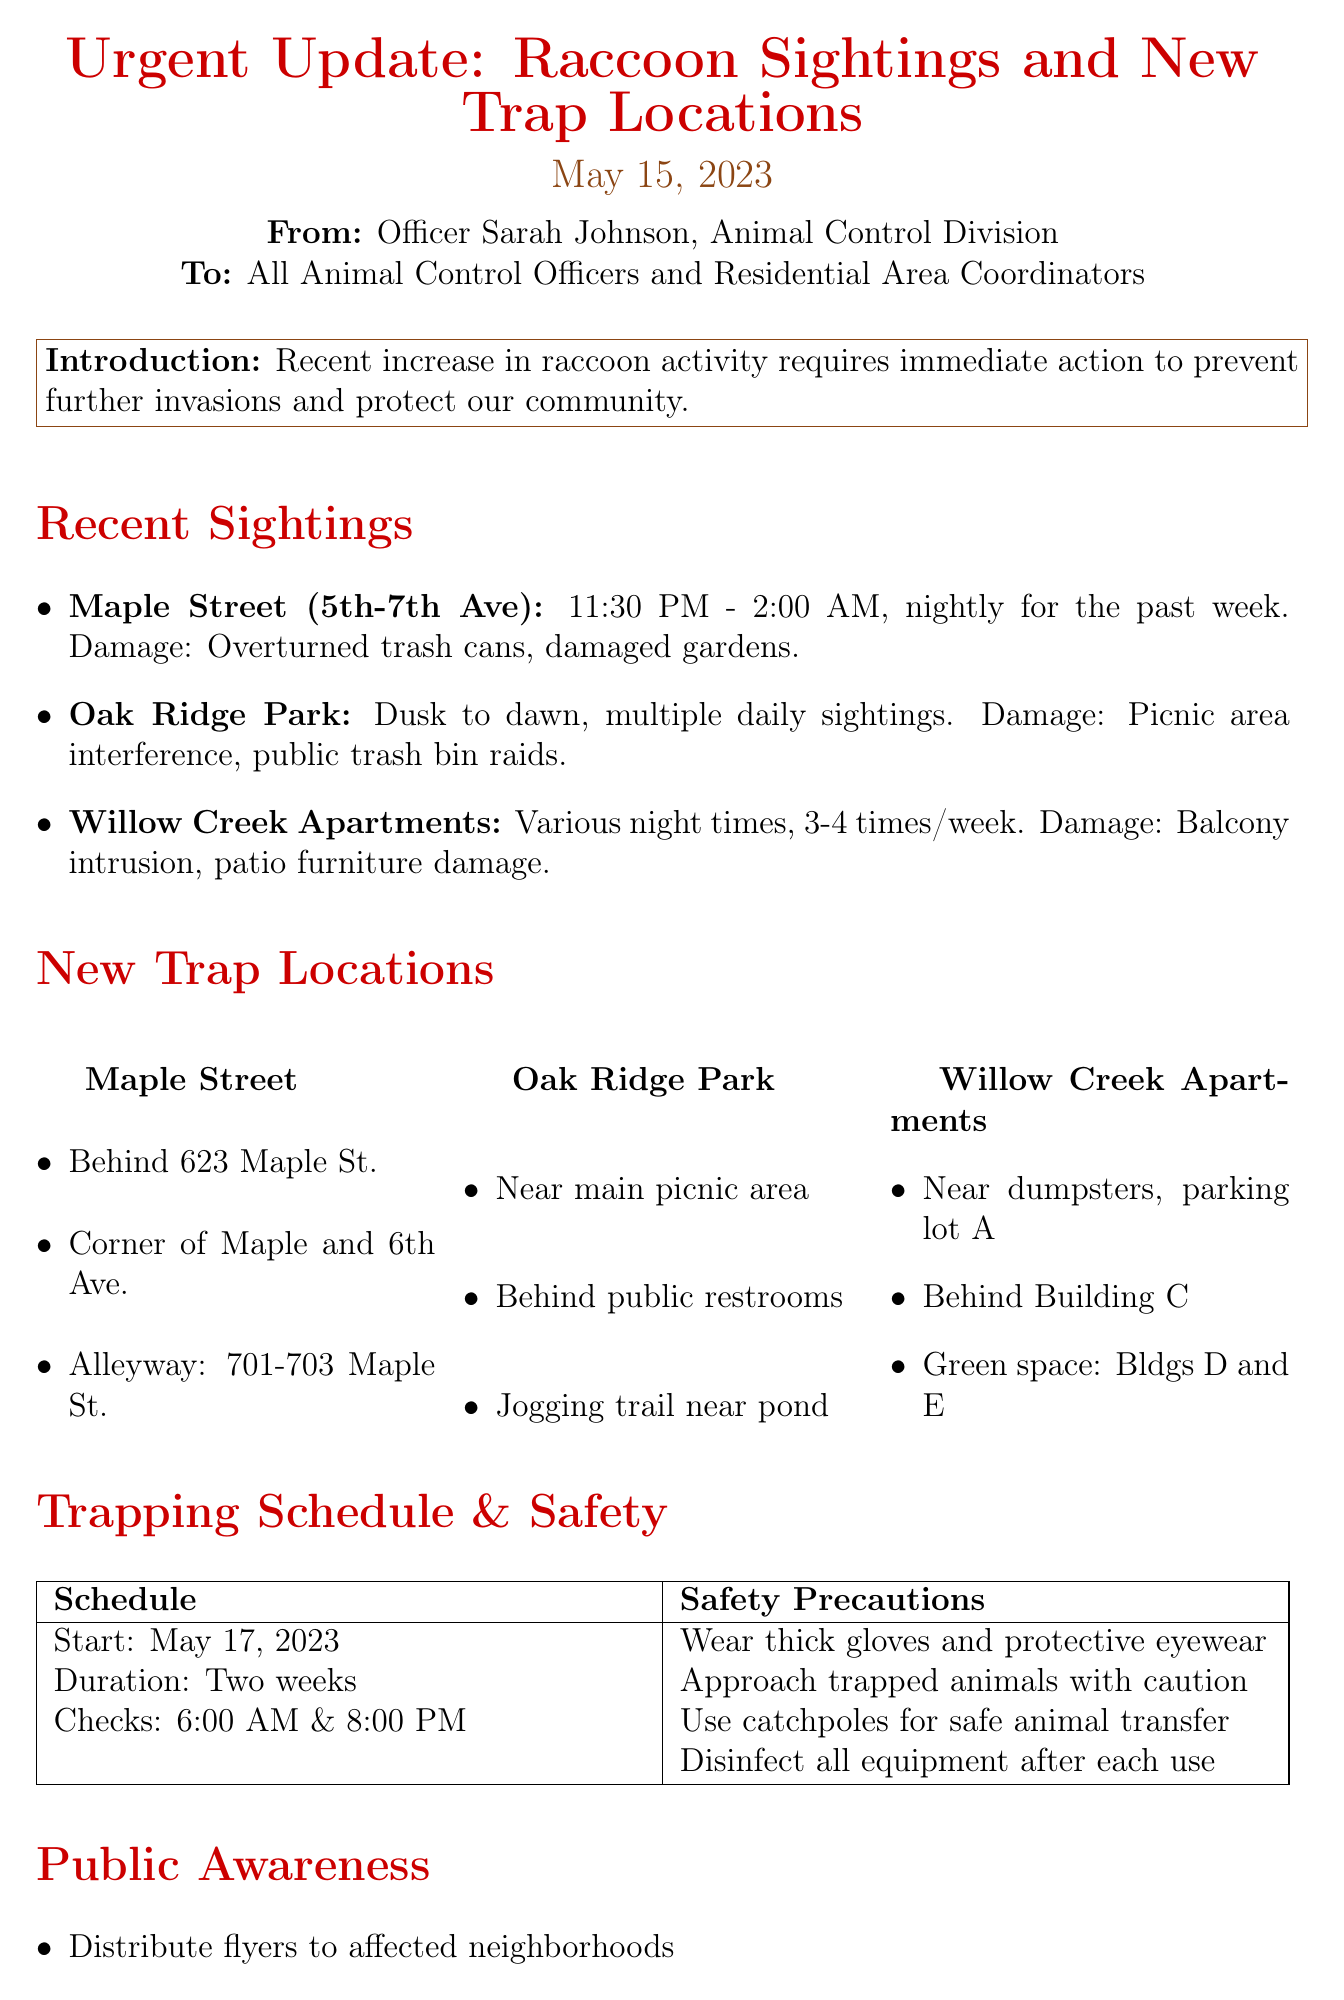What is the date of the memo? The date of the memo is stated at the top of the document.
Answer: May 15, 2023 Who is the author of the memo? The author is mentioned in the introduction section.
Answer: Officer Sarah Johnson What area has nightly sightings? Specific locations are listed under recent sightings; one area has nightly occurrence.
Answer: Maple Street How often will traps be checked? The trapping schedule specifies the frequency of checks in the document.
Answer: Twice daily When does the trapping start? The start date is clearly mentioned under the trapping schedule section.
Answer: May 17, 2023 What type of traps are used in Willow Creek Apartments? The document specifies the trap type used in each area under new trap locations.
Answer: Foothold traps (rubber-padded) What is the duration of the trapping schedule? The duration is outlined under the trapping schedule part of the memo.
Answer: Two weeks What should officers wear when handling traps? The safety precautions section lists the required protective gear.
Answer: Thick gloves and protective eyewear What is the emergency hotline number? The contact information section provides the emergency hotline.
Answer: 555-RACCOON (555-722-2666) 